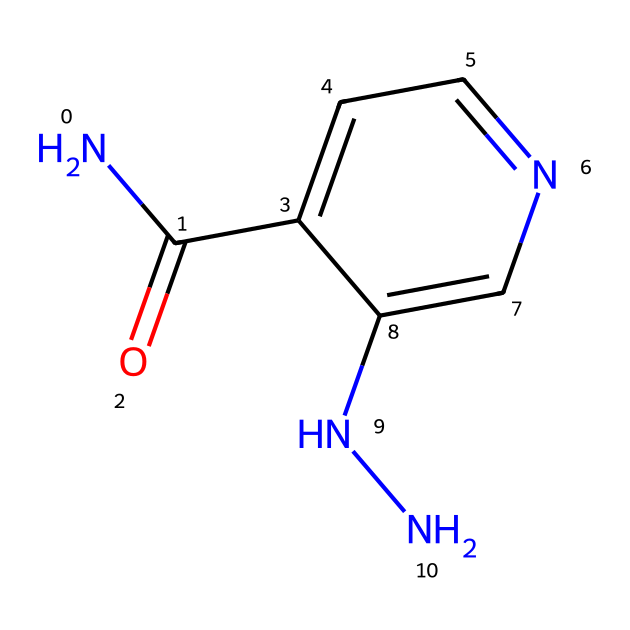How many nitrogen atoms are in isoniazid? The SMILES representation indicates there are two 'N' characters, which represent nitrogen atoms.
Answer: 2 What is the functional group in isoniazid? The 'C(=O)' segment indicates the presence of a carbonyl group (a carbon double-bonded to an oxygen), which is a defining feature of amides.
Answer: carbonyl What type of compound is isoniazid classified as? The structure contains hydrazine (two nitrogen atoms connected to hydrogens) and an amide functional group, which classifies it as a hydrazine derivative.
Answer: hydrazine derivative How many rings are present in the structure of isoniazid? Analyzing the structure reveals that there is only one aromatic ring (the 'c1ccncc1' portion indicates an aromatic structure) in the compound.
Answer: 1 What role does isoniazid play in medicine? Isoniazid is primarily used for the treatment of tuberculosis, targeting the bacteria that cause this infectious disease.
Answer: tuberculosis treatment What does the 'c' in the SMILES representation denote? The lowercase 'c' indicates that the carbon atoms are part of an aromatic ring system, highlighting the structure's cyclic and resonance features.
Answer: aromatic carbon 